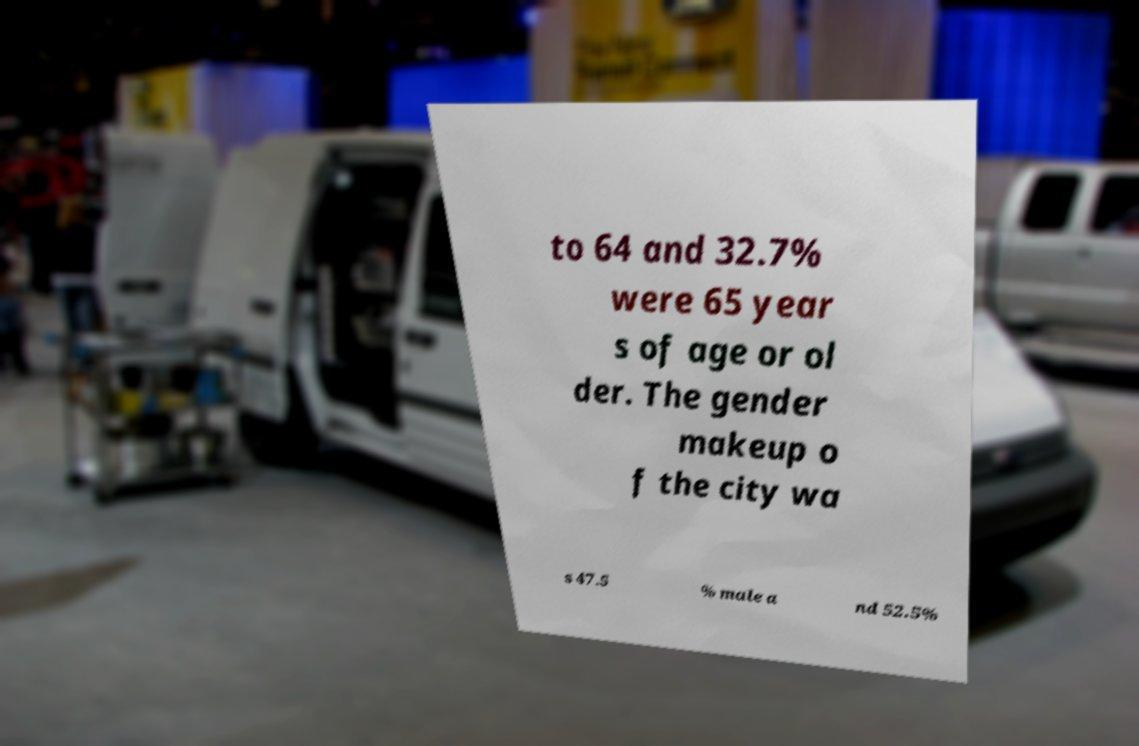For documentation purposes, I need the text within this image transcribed. Could you provide that? to 64 and 32.7% were 65 year s of age or ol der. The gender makeup o f the city wa s 47.5 % male a nd 52.5% 